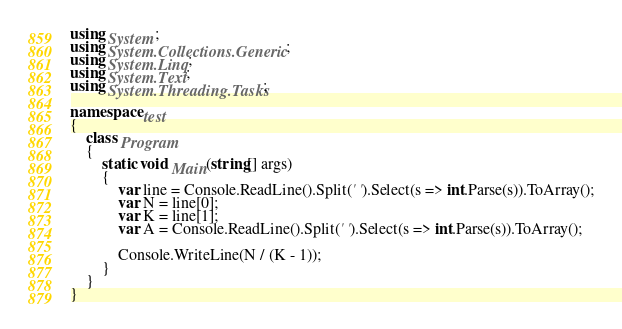Convert code to text. <code><loc_0><loc_0><loc_500><loc_500><_C#_>using System;
using System.Collections.Generic;
using System.Linq;
using System.Text;
using System.Threading.Tasks;

namespace test
{
    class Program
    {
        static void Main(string[] args)
        {
            var line = Console.ReadLine().Split(' ').Select(s => int.Parse(s)).ToArray();
            var N = line[0];
            var K = line[1];
            var A = Console.ReadLine().Split(' ').Select(s => int.Parse(s)).ToArray();

            Console.WriteLine(N / (K - 1));
        }
    }
}</code> 